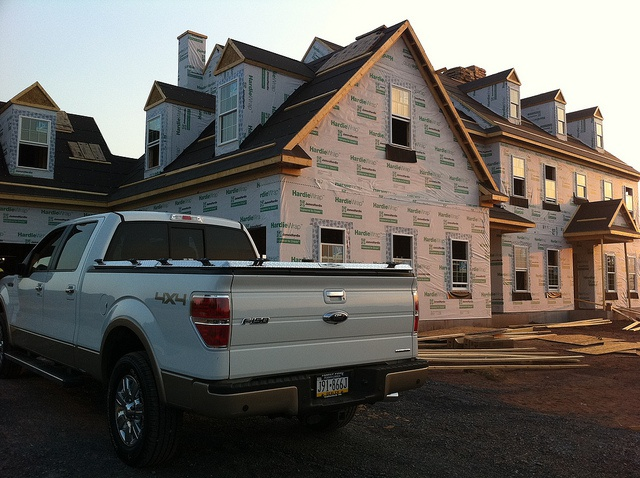Describe the objects in this image and their specific colors. I can see a truck in darkgray, black, gray, and purple tones in this image. 